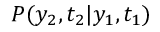Convert formula to latex. <formula><loc_0><loc_0><loc_500><loc_500>P ( y _ { 2 } , t _ { 2 } | y _ { 1 } , t _ { 1 } )</formula> 